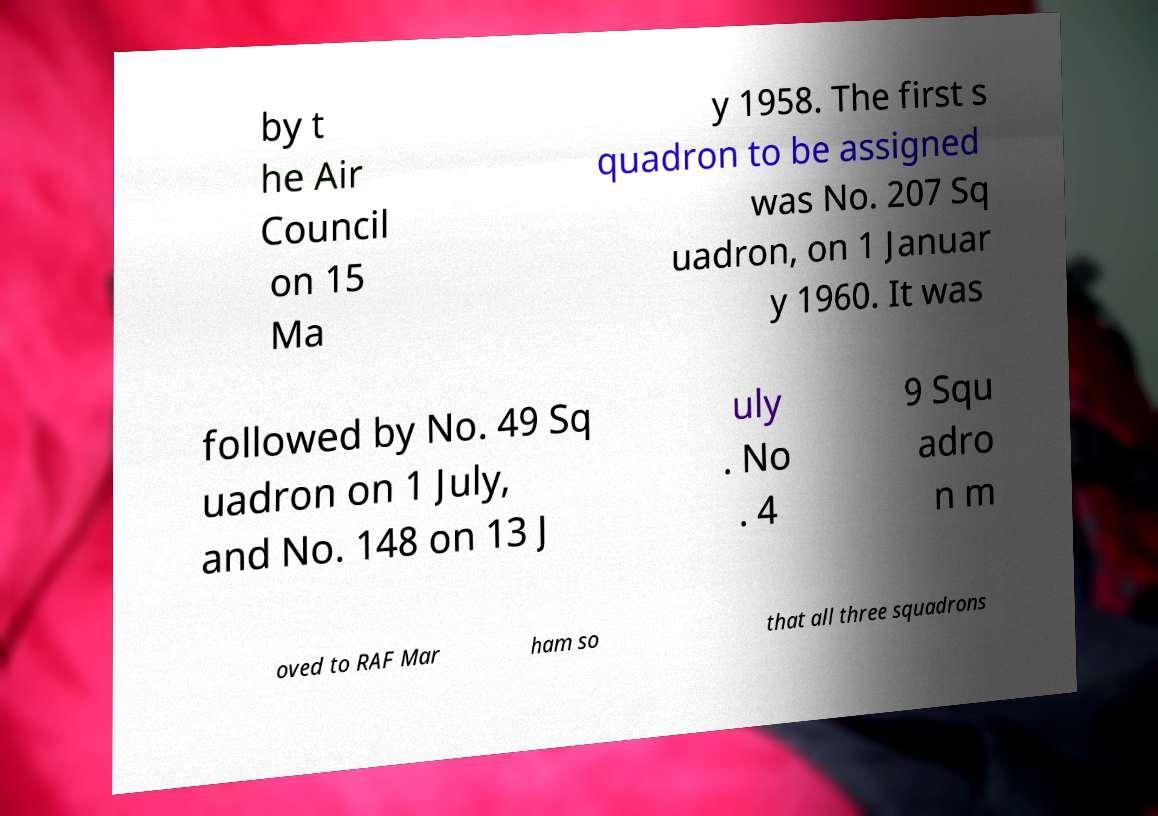Could you extract and type out the text from this image? by t he Air Council on 15 Ma y 1958. The first s quadron to be assigned was No. 207 Sq uadron, on 1 Januar y 1960. It was followed by No. 49 Sq uadron on 1 July, and No. 148 on 13 J uly . No . 4 9 Squ adro n m oved to RAF Mar ham so that all three squadrons 